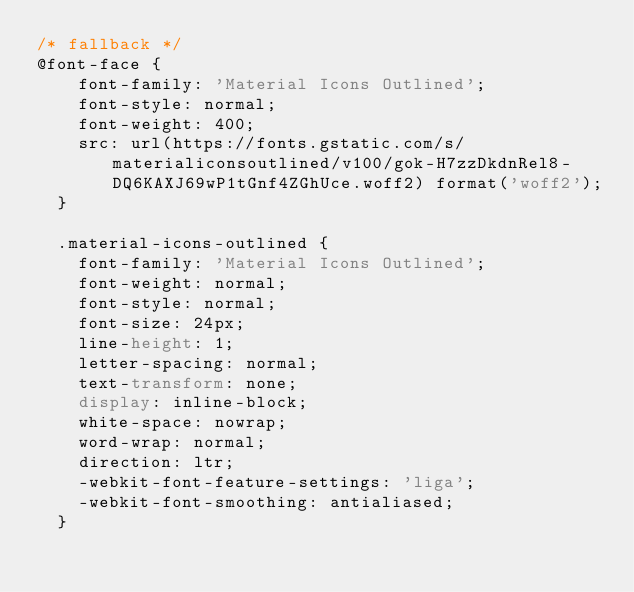<code> <loc_0><loc_0><loc_500><loc_500><_CSS_>/* fallback */
@font-face {
    font-family: 'Material Icons Outlined';
    font-style: normal;
    font-weight: 400;
    src: url(https://fonts.gstatic.com/s/materialiconsoutlined/v100/gok-H7zzDkdnRel8-DQ6KAXJ69wP1tGnf4ZGhUce.woff2) format('woff2');
  }
  
  .material-icons-outlined {
    font-family: 'Material Icons Outlined';
    font-weight: normal;
    font-style: normal;
    font-size: 24px;
    line-height: 1;
    letter-spacing: normal;
    text-transform: none;
    display: inline-block;
    white-space: nowrap;
    word-wrap: normal;
    direction: ltr;
    -webkit-font-feature-settings: 'liga';
    -webkit-font-smoothing: antialiased;
  }</code> 